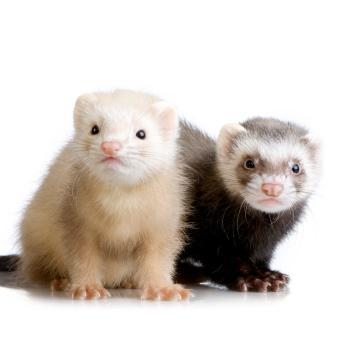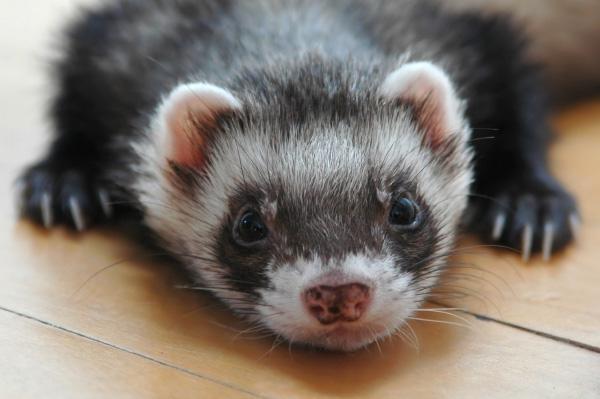The first image is the image on the left, the second image is the image on the right. Given the left and right images, does the statement "One image contains a pair of ferrets." hold true? Answer yes or no. Yes. 